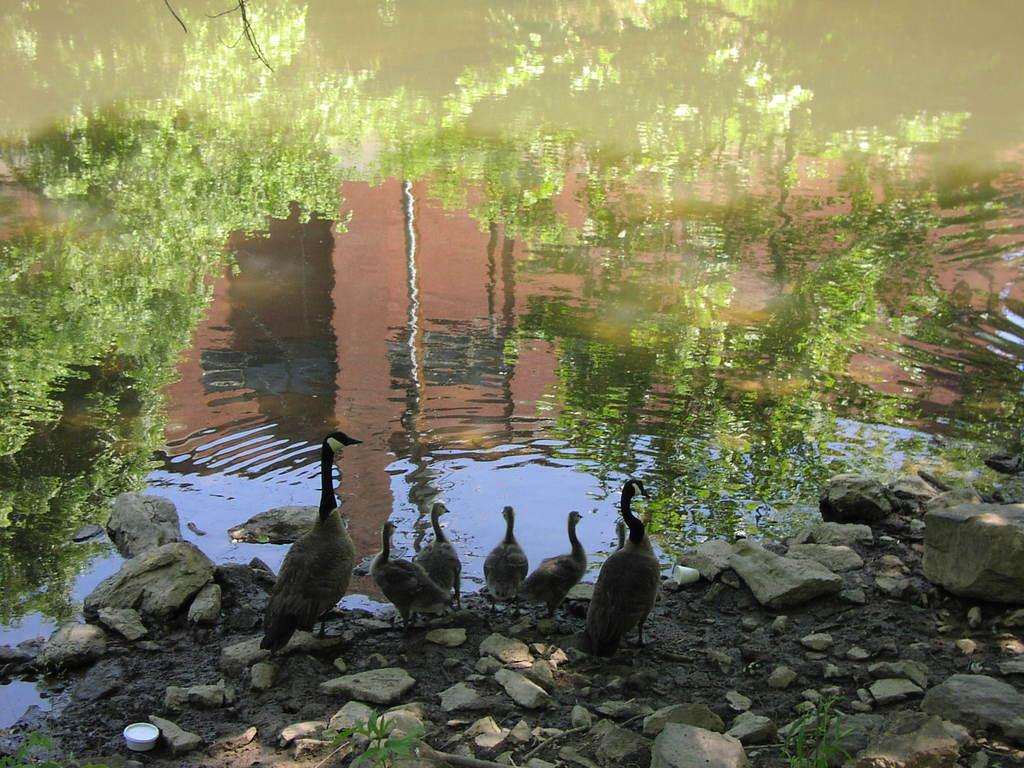What is the primary element visible in the image? There is water in the image. What can be seen reflected on the surface of the water? There is a reflection of trees on the water. What type of animals can be seen at the bottom of the image? There are birds visible at the bottom of the image. What type of objects are present in the water? There are stones in the image. How does the wind affect the parcel in the image? There is no parcel present in the image, so the wind's effect cannot be determined. What type of insect can be seen crawling on the stones in the image? There is no insect visible in the image, so it cannot be determined what type of insect might be present. 